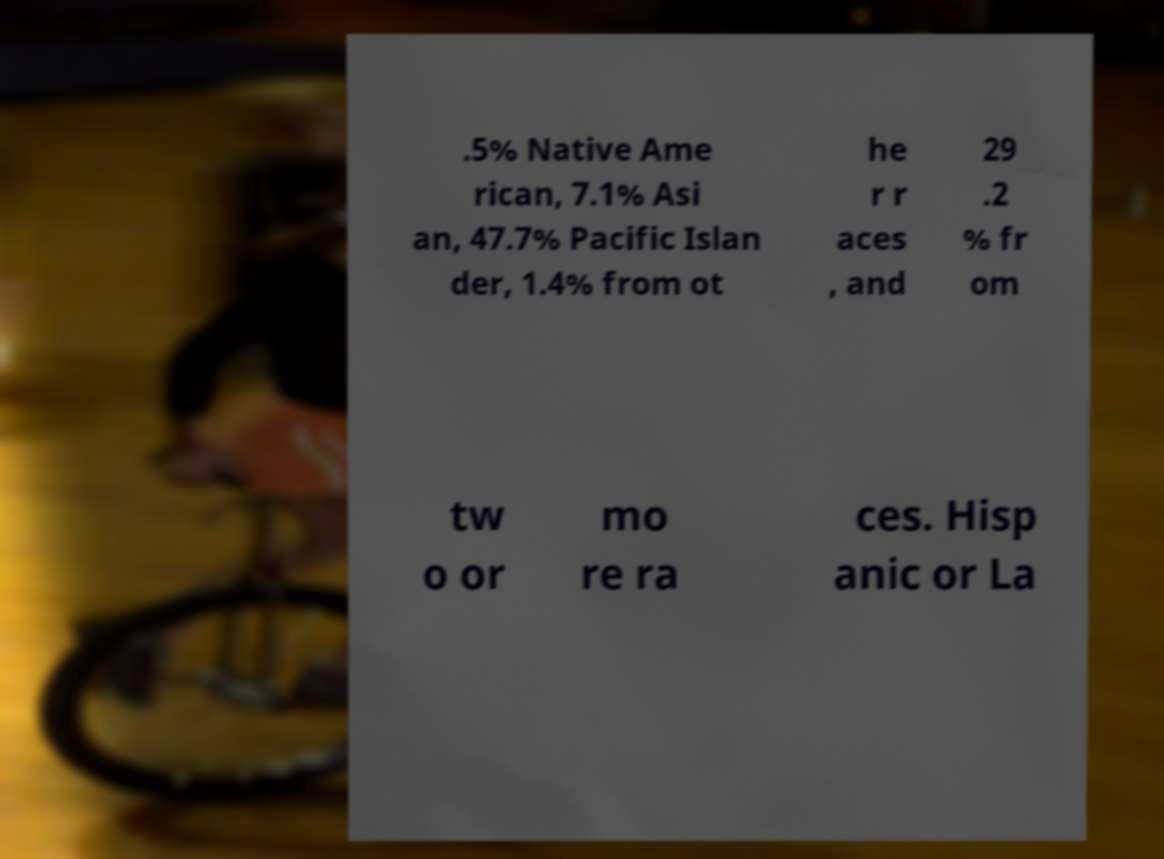Can you read and provide the text displayed in the image?This photo seems to have some interesting text. Can you extract and type it out for me? .5% Native Ame rican, 7.1% Asi an, 47.7% Pacific Islan der, 1.4% from ot he r r aces , and 29 .2 % fr om tw o or mo re ra ces. Hisp anic or La 